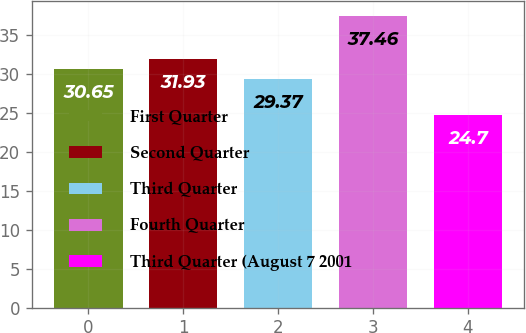Convert chart. <chart><loc_0><loc_0><loc_500><loc_500><bar_chart><fcel>First Quarter<fcel>Second Quarter<fcel>Third Quarter<fcel>Fourth Quarter<fcel>Third Quarter (August 7 2001<nl><fcel>30.65<fcel>31.93<fcel>29.37<fcel>37.46<fcel>24.7<nl></chart> 